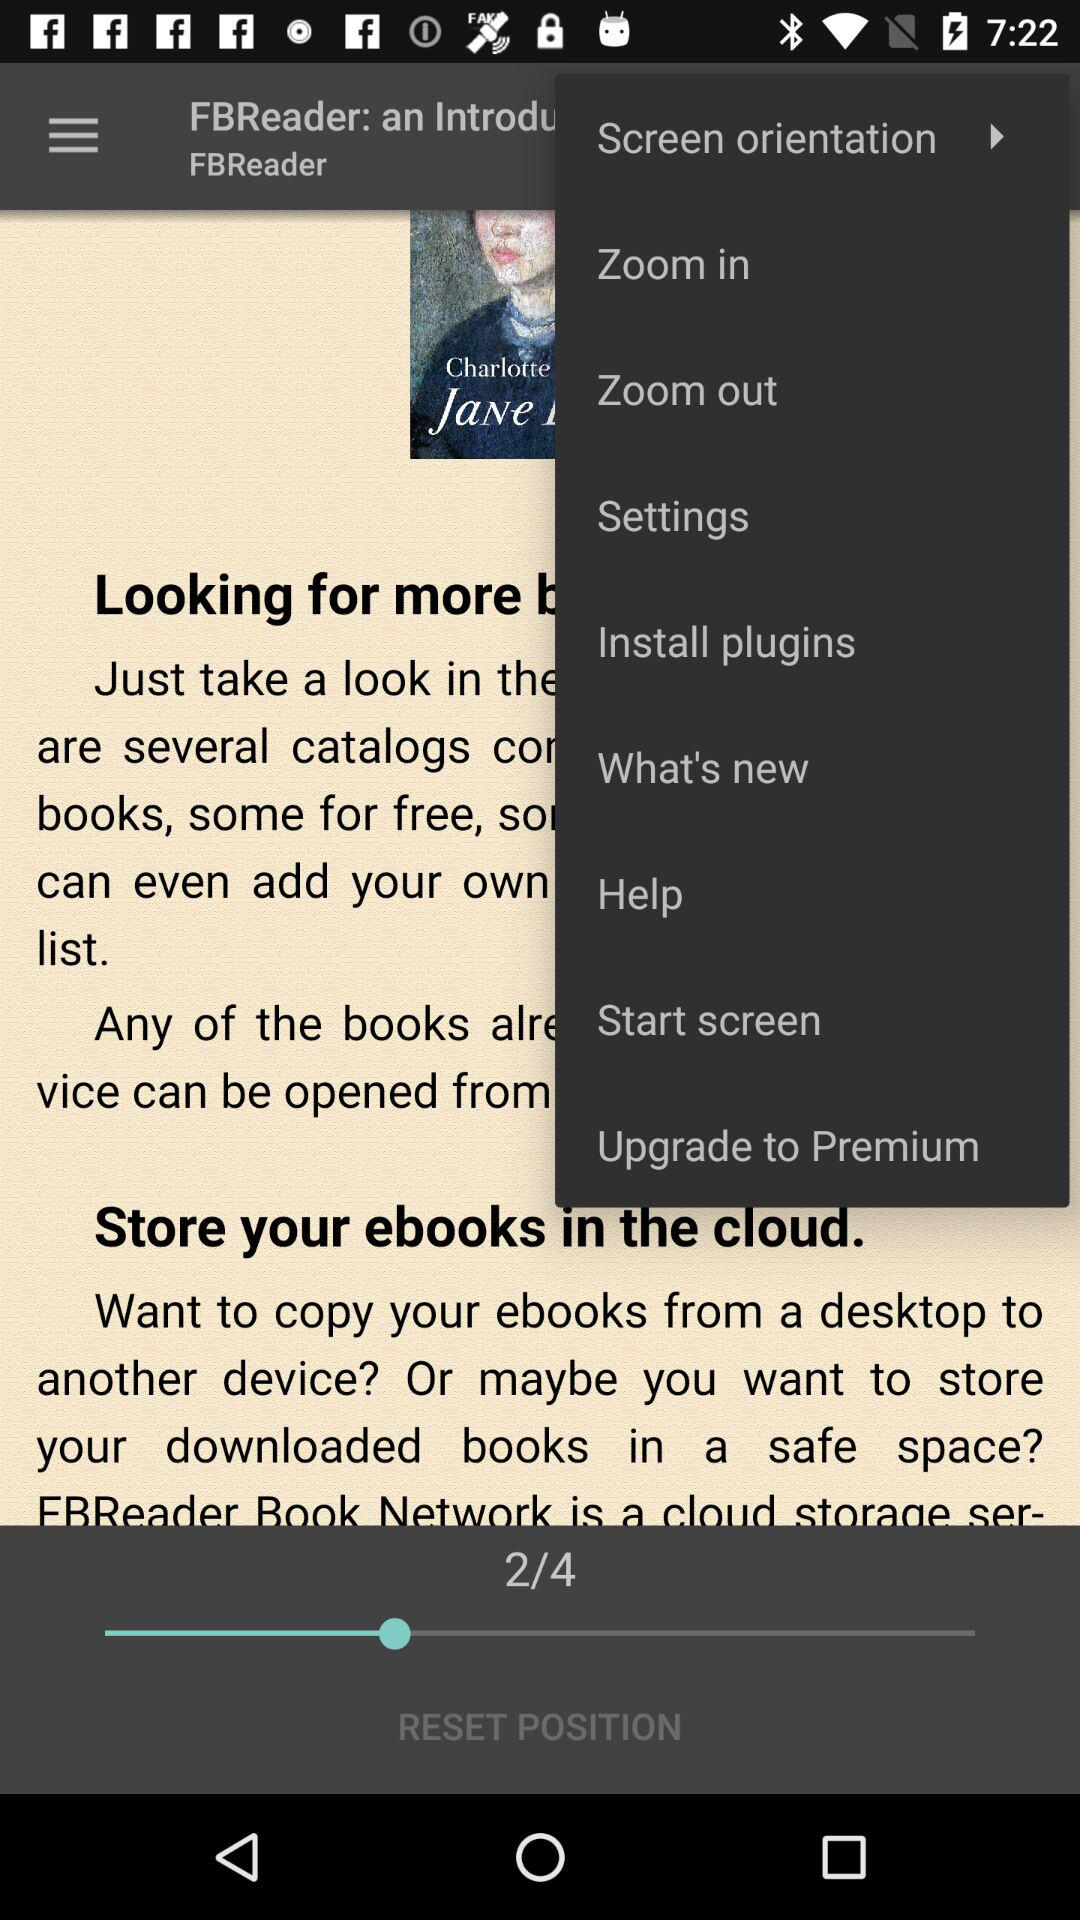Which is the current page number? The current page number is 2. 